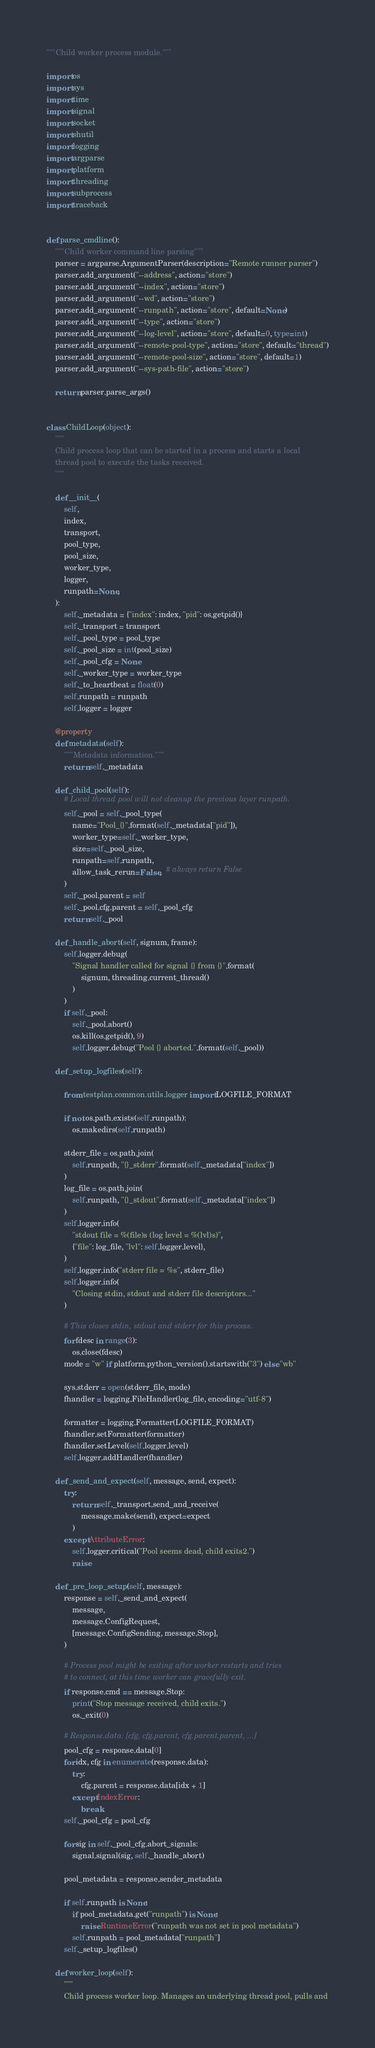<code> <loc_0><loc_0><loc_500><loc_500><_Python_>"""Child worker process module."""

import os
import sys
import time
import signal
import socket
import shutil
import logging
import argparse
import platform
import threading
import subprocess
import traceback


def parse_cmdline():
    """Child worker command line parsing"""
    parser = argparse.ArgumentParser(description="Remote runner parser")
    parser.add_argument("--address", action="store")
    parser.add_argument("--index", action="store")
    parser.add_argument("--wd", action="store")
    parser.add_argument("--runpath", action="store", default=None)
    parser.add_argument("--type", action="store")
    parser.add_argument("--log-level", action="store", default=0, type=int)
    parser.add_argument("--remote-pool-type", action="store", default="thread")
    parser.add_argument("--remote-pool-size", action="store", default=1)
    parser.add_argument("--sys-path-file", action="store")

    return parser.parse_args()


class ChildLoop(object):
    """
    Child process loop that can be started in a process and starts a local
    thread pool to execute the tasks received.
    """

    def __init__(
        self,
        index,
        transport,
        pool_type,
        pool_size,
        worker_type,
        logger,
        runpath=None,
    ):
        self._metadata = {"index": index, "pid": os.getpid()}
        self._transport = transport
        self._pool_type = pool_type
        self._pool_size = int(pool_size)
        self._pool_cfg = None
        self._worker_type = worker_type
        self._to_heartbeat = float(0)
        self.runpath = runpath
        self.logger = logger

    @property
    def metadata(self):
        """Metadata information."""
        return self._metadata

    def _child_pool(self):
        # Local thread pool will not cleanup the previous layer runpath.
        self._pool = self._pool_type(
            name="Pool_{}".format(self._metadata["pid"]),
            worker_type=self._worker_type,
            size=self._pool_size,
            runpath=self.runpath,
            allow_task_rerun=False,  # always return False
        )
        self._pool.parent = self
        self._pool.cfg.parent = self._pool_cfg
        return self._pool

    def _handle_abort(self, signum, frame):
        self.logger.debug(
            "Signal handler called for signal {} from {}".format(
                signum, threading.current_thread()
            )
        )
        if self._pool:
            self._pool.abort()
            os.kill(os.getpid(), 9)
            self.logger.debug("Pool {} aborted.".format(self._pool))

    def _setup_logfiles(self):

        from testplan.common.utils.logger import LOGFILE_FORMAT

        if not os.path.exists(self.runpath):
            os.makedirs(self.runpath)

        stderr_file = os.path.join(
            self.runpath, "{}_stderr".format(self._metadata["index"])
        )
        log_file = os.path.join(
            self.runpath, "{}_stdout".format(self._metadata["index"])
        )
        self.logger.info(
            "stdout file = %(file)s (log level = %(lvl)s)",
            {"file": log_file, "lvl": self.logger.level},
        )
        self.logger.info("stderr file = %s", stderr_file)
        self.logger.info(
            "Closing stdin, stdout and stderr file descriptors..."
        )

        # This closes stdin, stdout and stderr for this process.
        for fdesc in range(3):
            os.close(fdesc)
        mode = "w" if platform.python_version().startswith("3") else "wb"

        sys.stderr = open(stderr_file, mode)
        fhandler = logging.FileHandler(log_file, encoding="utf-8")

        formatter = logging.Formatter(LOGFILE_FORMAT)
        fhandler.setFormatter(formatter)
        fhandler.setLevel(self.logger.level)
        self.logger.addHandler(fhandler)

    def _send_and_expect(self, message, send, expect):
        try:
            return self._transport.send_and_receive(
                message.make(send), expect=expect
            )
        except AttributeError:
            self.logger.critical("Pool seems dead, child exits2.")
            raise

    def _pre_loop_setup(self, message):
        response = self._send_and_expect(
            message,
            message.ConfigRequest,
            [message.ConfigSending, message.Stop],
        )

        # Process pool might be exiting after worker restarts and tries
        # to connect, at this time worker can gracefully exit.
        if response.cmd == message.Stop:
            print("Stop message received, child exits.")
            os._exit(0)

        # Response.data: [cfg, cfg.parent, cfg.parent.parent, ...]
        pool_cfg = response.data[0]
        for idx, cfg in enumerate(response.data):
            try:
                cfg.parent = response.data[idx + 1]
            except IndexError:
                break
        self._pool_cfg = pool_cfg

        for sig in self._pool_cfg.abort_signals:
            signal.signal(sig, self._handle_abort)

        pool_metadata = response.sender_metadata

        if self.runpath is None:
            if pool_metadata.get("runpath") is None:
                raise RuntimeError("runpath was not set in pool metadata")
            self.runpath = pool_metadata["runpath"]
        self._setup_logfiles()

    def worker_loop(self):
        """
        Child process worker loop. Manages an underlying thread pool, pulls and</code> 